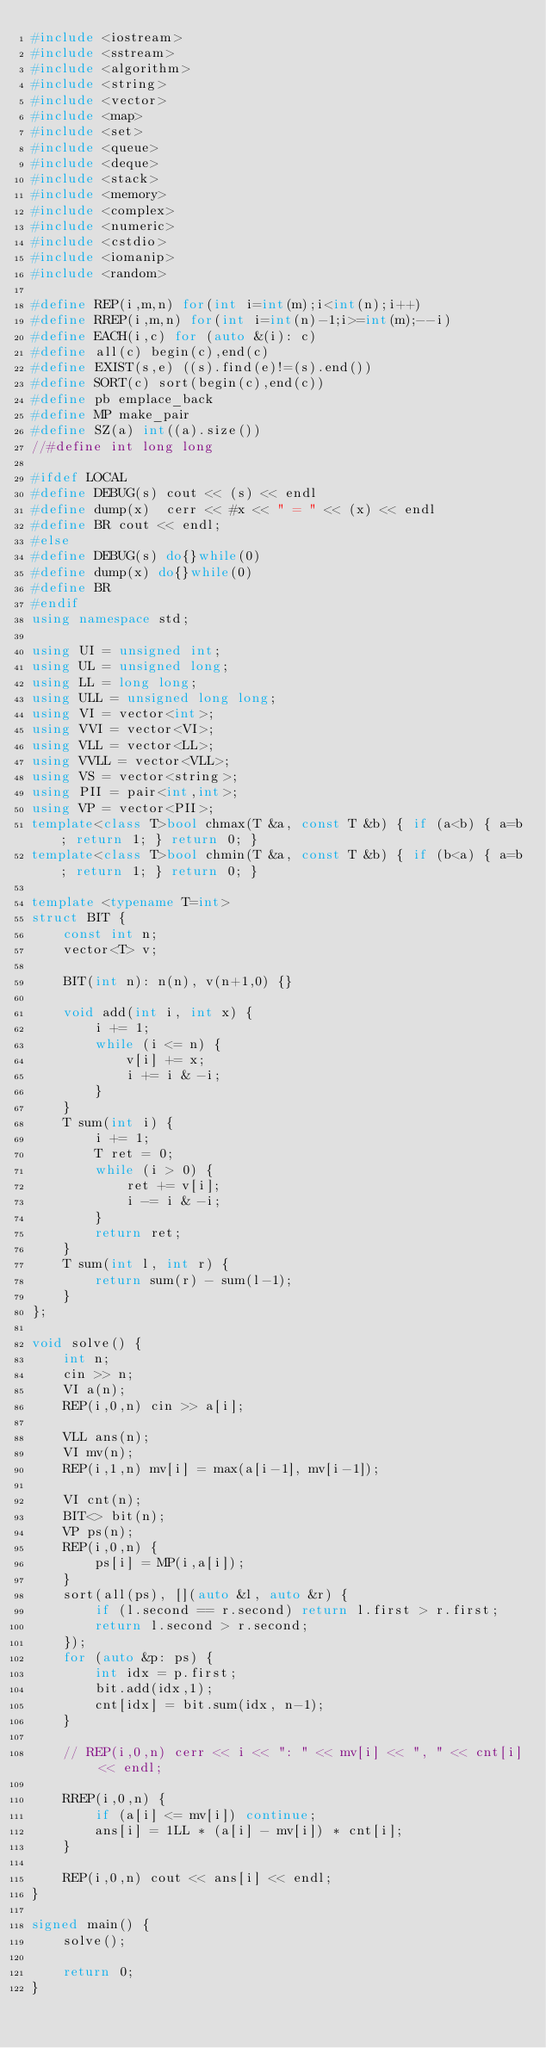Convert code to text. <code><loc_0><loc_0><loc_500><loc_500><_C++_>#include <iostream>
#include <sstream>
#include <algorithm>
#include <string>
#include <vector>
#include <map>
#include <set>
#include <queue>
#include <deque>
#include <stack>
#include <memory>
#include <complex>
#include <numeric>
#include <cstdio>
#include <iomanip>
#include <random>

#define REP(i,m,n) for(int i=int(m);i<int(n);i++)
#define RREP(i,m,n) for(int i=int(n)-1;i>=int(m);--i)
#define EACH(i,c) for (auto &(i): c)
#define all(c) begin(c),end(c)
#define EXIST(s,e) ((s).find(e)!=(s).end())
#define SORT(c) sort(begin(c),end(c))
#define pb emplace_back
#define MP make_pair
#define SZ(a) int((a).size())
//#define int long long

#ifdef LOCAL
#define DEBUG(s) cout << (s) << endl
#define dump(x)  cerr << #x << " = " << (x) << endl
#define BR cout << endl;
#else
#define DEBUG(s) do{}while(0)
#define dump(x) do{}while(0)
#define BR 
#endif
using namespace std;

using UI = unsigned int;
using UL = unsigned long;
using LL = long long;
using ULL = unsigned long long;
using VI = vector<int>;
using VVI = vector<VI>;
using VLL = vector<LL>;
using VVLL = vector<VLL>;
using VS = vector<string>;
using PII = pair<int,int>;
using VP = vector<PII>;
template<class T>bool chmax(T &a, const T &b) { if (a<b) { a=b; return 1; } return 0; }
template<class T>bool chmin(T &a, const T &b) { if (b<a) { a=b; return 1; } return 0; }

template <typename T=int>
struct BIT {
    const int n;
    vector<T> v;

    BIT(int n): n(n), v(n+1,0) {}

    void add(int i, int x) {
        i += 1;
        while (i <= n) {
            v[i] += x;
            i += i & -i;
        }
    }
    T sum(int i) {
        i += 1;
        T ret = 0;
        while (i > 0) {
            ret += v[i];
            i -= i & -i;
        }
        return ret;
    }
    T sum(int l, int r) {
        return sum(r) - sum(l-1);
    }
};

void solve() {
    int n;
    cin >> n;
    VI a(n);
    REP(i,0,n) cin >> a[i];

    VLL ans(n);
    VI mv(n);
    REP(i,1,n) mv[i] = max(a[i-1], mv[i-1]);

    VI cnt(n);
    BIT<> bit(n);
    VP ps(n);
    REP(i,0,n) {
        ps[i] = MP(i,a[i]);
    }
    sort(all(ps), [](auto &l, auto &r) {
        if (l.second == r.second) return l.first > r.first;
        return l.second > r.second;
    });
    for (auto &p: ps) {
        int idx = p.first;
        bit.add(idx,1);
        cnt[idx] = bit.sum(idx, n-1);
    }

    // REP(i,0,n) cerr << i << ": " << mv[i] << ", " << cnt[i] << endl;

    RREP(i,0,n) {
        if (a[i] <= mv[i]) continue;
        ans[i] = 1LL * (a[i] - mv[i]) * cnt[i];
    }

    REP(i,0,n) cout << ans[i] << endl;
}

signed main() {
    solve();
    
    return 0;
}</code> 